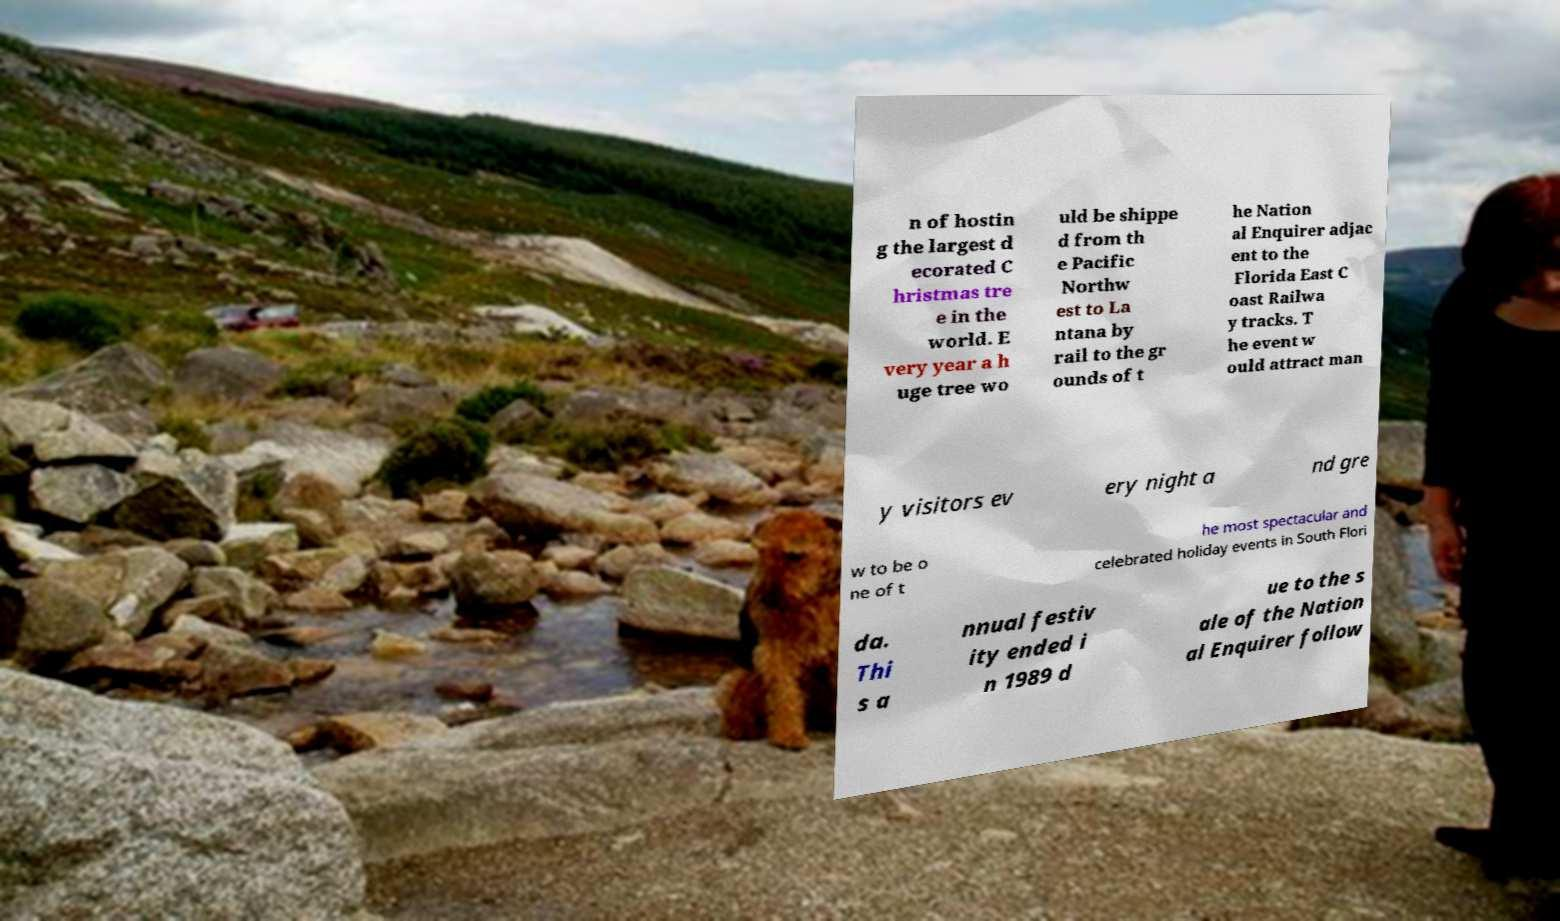Please identify and transcribe the text found in this image. n of hostin g the largest d ecorated C hristmas tre e in the world. E very year a h uge tree wo uld be shippe d from th e Pacific Northw est to La ntana by rail to the gr ounds of t he Nation al Enquirer adjac ent to the Florida East C oast Railwa y tracks. T he event w ould attract man y visitors ev ery night a nd gre w to be o ne of t he most spectacular and celebrated holiday events in South Flori da. Thi s a nnual festiv ity ended i n 1989 d ue to the s ale of the Nation al Enquirer follow 